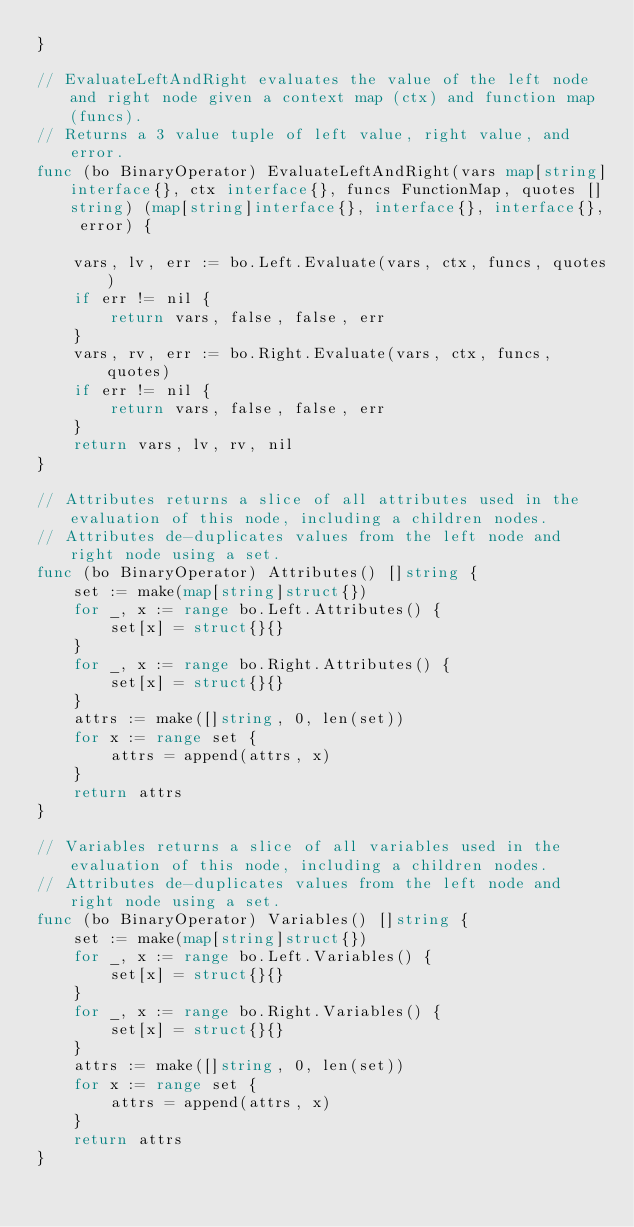Convert code to text. <code><loc_0><loc_0><loc_500><loc_500><_Go_>}

// EvaluateLeftAndRight evaluates the value of the left node and right node given a context map (ctx) and function map (funcs).
// Returns a 3 value tuple of left value, right value, and error.
func (bo BinaryOperator) EvaluateLeftAndRight(vars map[string]interface{}, ctx interface{}, funcs FunctionMap, quotes []string) (map[string]interface{}, interface{}, interface{}, error) {

	vars, lv, err := bo.Left.Evaluate(vars, ctx, funcs, quotes)
	if err != nil {
		return vars, false, false, err
	}
	vars, rv, err := bo.Right.Evaluate(vars, ctx, funcs, quotes)
	if err != nil {
		return vars, false, false, err
	}
	return vars, lv, rv, nil
}

// Attributes returns a slice of all attributes used in the evaluation of this node, including a children nodes.
// Attributes de-duplicates values from the left node and right node using a set.
func (bo BinaryOperator) Attributes() []string {
	set := make(map[string]struct{})
	for _, x := range bo.Left.Attributes() {
		set[x] = struct{}{}
	}
	for _, x := range bo.Right.Attributes() {
		set[x] = struct{}{}
	}
	attrs := make([]string, 0, len(set))
	for x := range set {
		attrs = append(attrs, x)
	}
	return attrs
}

// Variables returns a slice of all variables used in the evaluation of this node, including a children nodes.
// Attributes de-duplicates values from the left node and right node using a set.
func (bo BinaryOperator) Variables() []string {
	set := make(map[string]struct{})
	for _, x := range bo.Left.Variables() {
		set[x] = struct{}{}
	}
	for _, x := range bo.Right.Variables() {
		set[x] = struct{}{}
	}
	attrs := make([]string, 0, len(set))
	for x := range set {
		attrs = append(attrs, x)
	}
	return attrs
}
</code> 